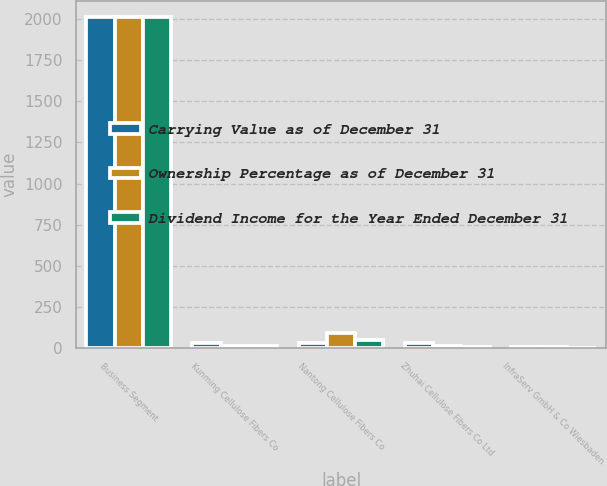Convert chart to OTSL. <chart><loc_0><loc_0><loc_500><loc_500><stacked_bar_chart><ecel><fcel>Business Segment<fcel>Kunming Cellulose Fibers Co<fcel>Nantong Cellulose Fibers Co<fcel>Zhuhai Cellulose Fibers Co Ltd<fcel>InfraServ GmbH & Co Wiesbaden<nl><fcel>Carrying Value as of December 31<fcel>2010<fcel>30<fcel>31<fcel>30<fcel>8<nl><fcel>Ownership Percentage as of December 31<fcel>2010<fcel>14<fcel>89<fcel>14<fcel>6<nl><fcel>Dividend Income for the Year Ended December 31<fcel>2010<fcel>11<fcel>51<fcel>9<fcel>2<nl></chart> 